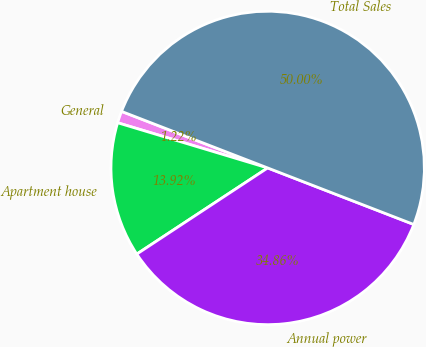<chart> <loc_0><loc_0><loc_500><loc_500><pie_chart><fcel>General<fcel>Apartment house<fcel>Annual power<fcel>Total Sales<nl><fcel>1.22%<fcel>13.92%<fcel>34.86%<fcel>50.0%<nl></chart> 